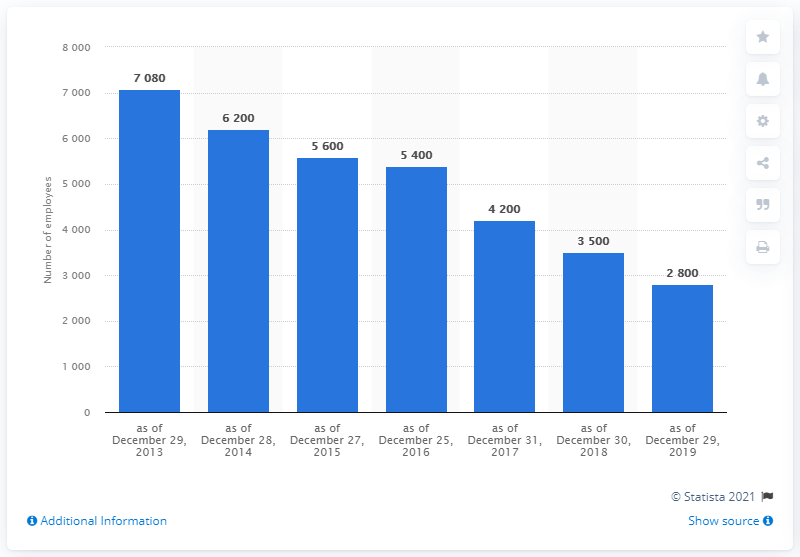Draw attention to some important aspects in this diagram. As of the historical record, the highest number of employees reached was 7080. The number of employees has been below 5000 for 3 months. 